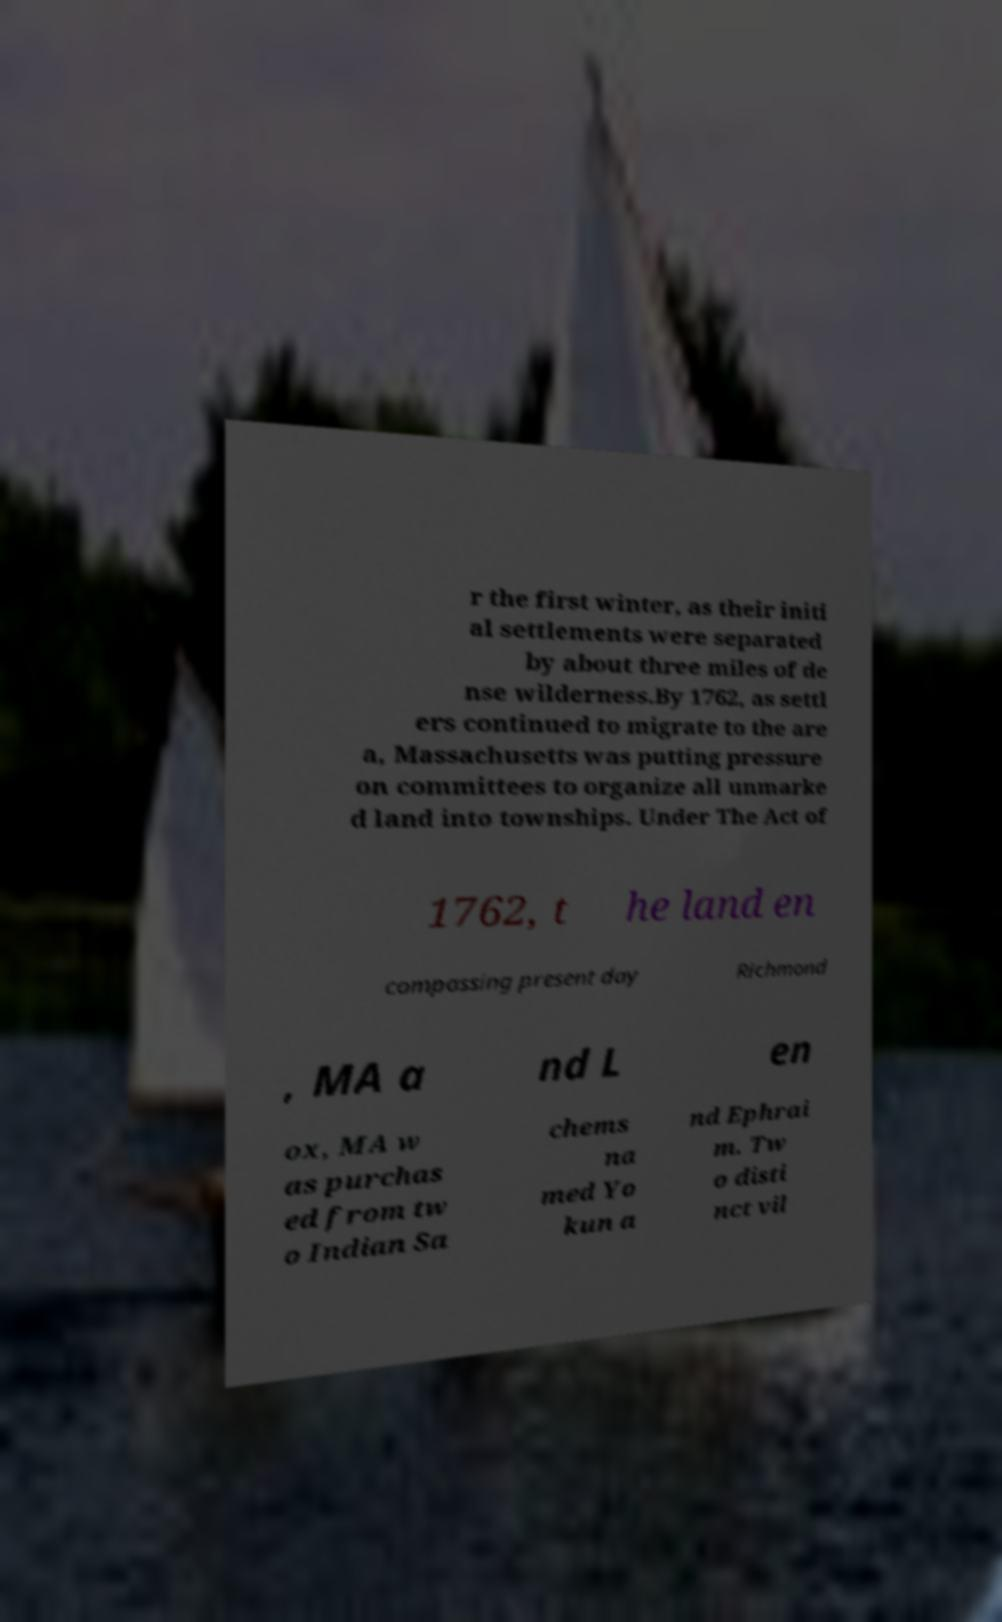I need the written content from this picture converted into text. Can you do that? r the first winter, as their initi al settlements were separated by about three miles of de nse wilderness.By 1762, as settl ers continued to migrate to the are a, Massachusetts was putting pressure on committees to organize all unmarke d land into townships. Under The Act of 1762, t he land en compassing present day Richmond , MA a nd L en ox, MA w as purchas ed from tw o Indian Sa chems na med Yo kun a nd Ephrai m. Tw o disti nct vil 